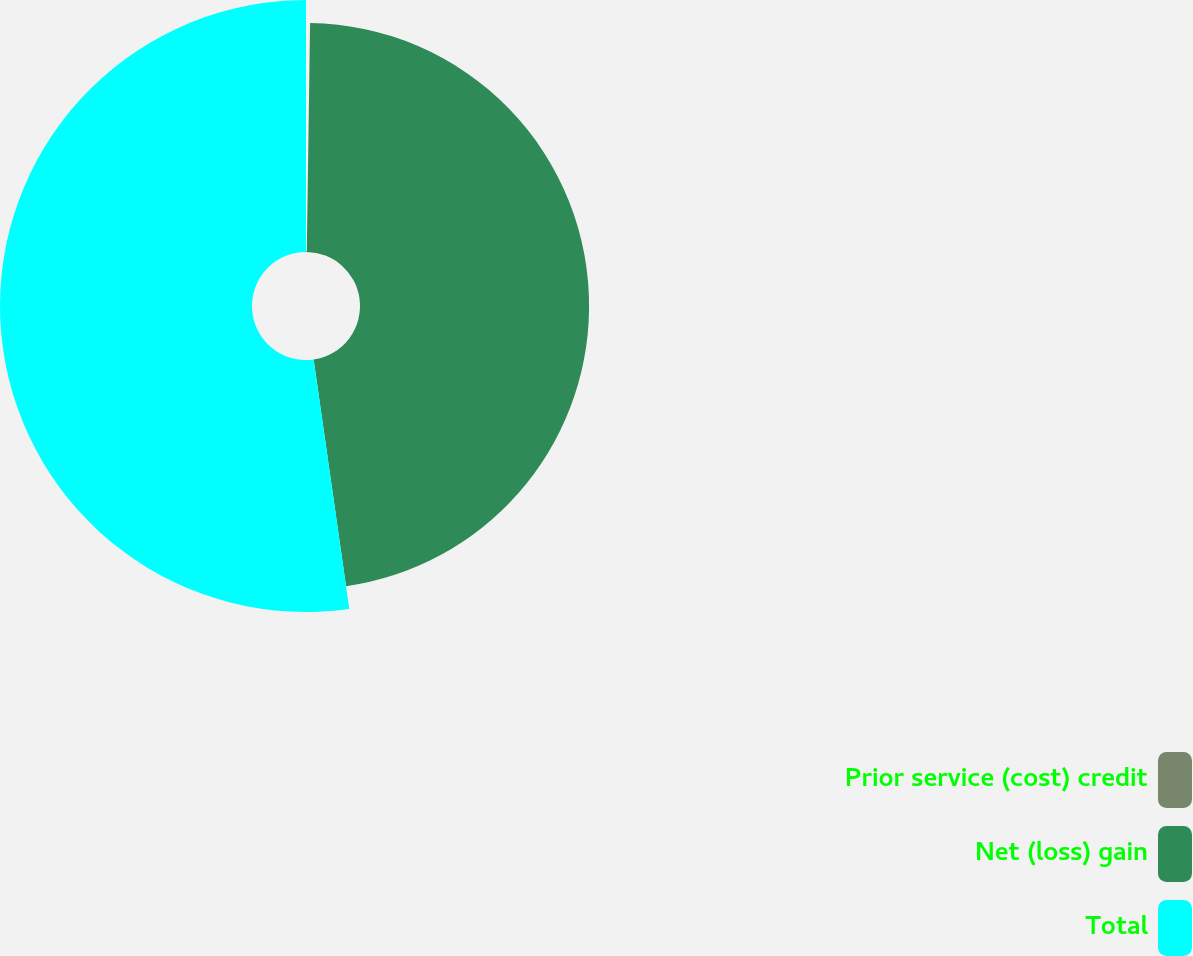<chart> <loc_0><loc_0><loc_500><loc_500><pie_chart><fcel>Prior service (cost) credit<fcel>Net (loss) gain<fcel>Total<nl><fcel>0.23%<fcel>47.51%<fcel>52.26%<nl></chart> 